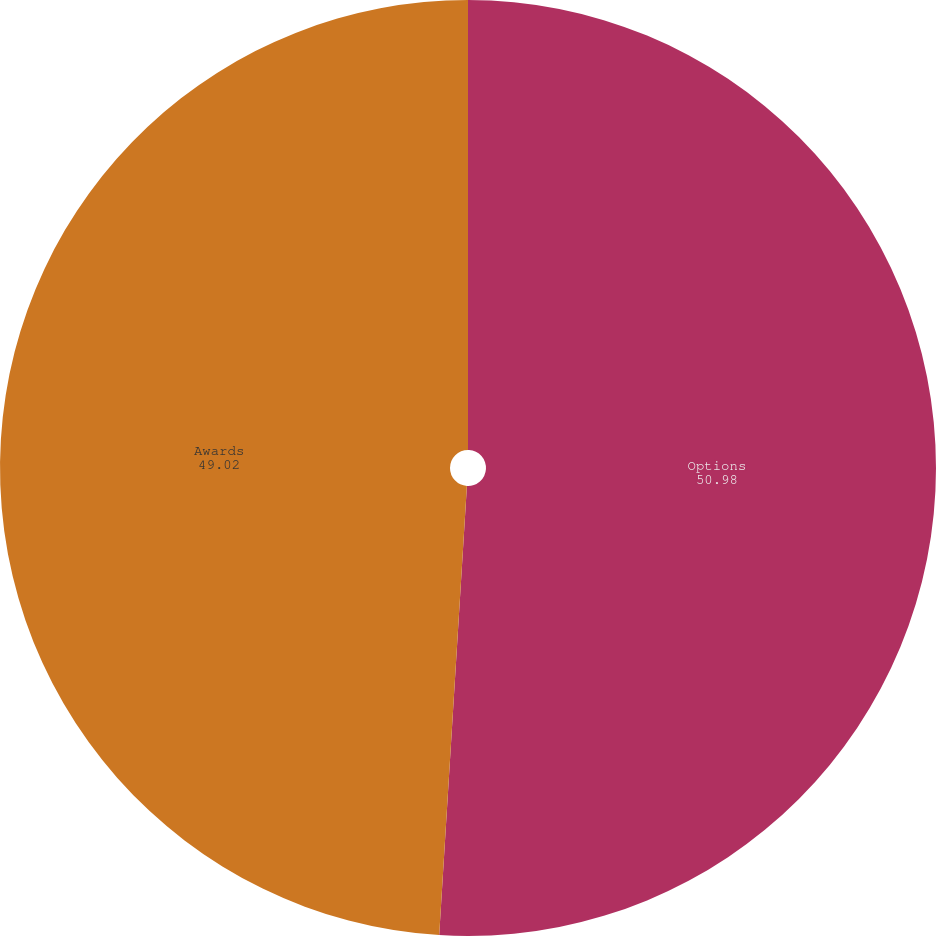Convert chart. <chart><loc_0><loc_0><loc_500><loc_500><pie_chart><fcel>Options<fcel>Awards<nl><fcel>50.98%<fcel>49.02%<nl></chart> 